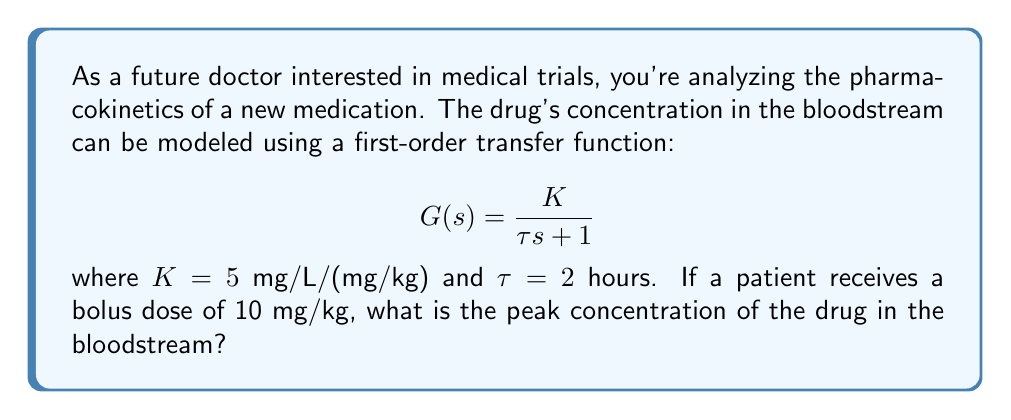Teach me how to tackle this problem. To solve this problem, we'll follow these steps:

1) The transfer function $G(s)$ represents the relationship between the input (drug dose) and the output (drug concentration in the bloodstream) in the Laplace domain.

2) For a first-order system with a step input (which a bolus dose approximates), the time-domain response is:

   $$c(t) = K(1 - e^{-t/\tau})$$

   where $c(t)$ is the concentration at time $t$.

3) The peak concentration will occur as $t$ approaches infinity, so we can find it by taking the limit:

   $$c_{peak} = \lim_{t \to \infty} K(1 - e^{-t/\tau}) = K$$

4) We're given that $K = 5$ mg/L/(mg/kg), but this is for a unit step input (1 mg/kg dose). Our actual dose is 10 mg/kg, so we need to multiply by 10:

   $$c_{peak} = 10 \cdot K = 10 \cdot 5 = 50 \text{ mg/L}$$

Thus, the peak concentration in the bloodstream will be 50 mg/L.
Answer: $50 \text{ mg/L}$ 